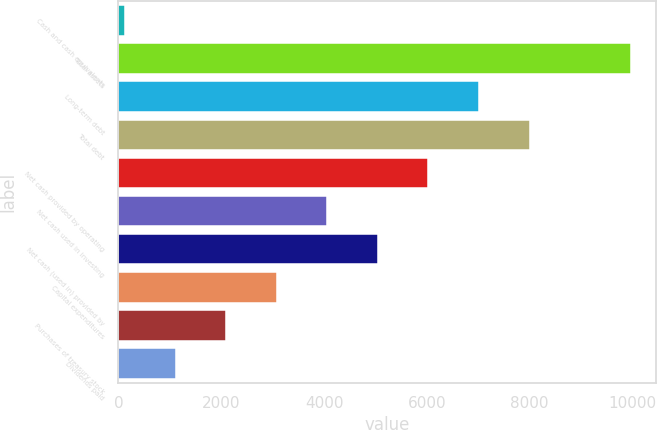Convert chart to OTSL. <chart><loc_0><loc_0><loc_500><loc_500><bar_chart><fcel>Cash and cash equivalents<fcel>Total assets<fcel>Long-term debt<fcel>Total debt<fcel>Net cash provided by operating<fcel>Net cash used in investing<fcel>Net cash (used in) provided by<fcel>Capital expenditures<fcel>Purchases of treasury stock<fcel>Dividends paid<nl><fcel>133<fcel>9962<fcel>7013.3<fcel>7996.2<fcel>6030.4<fcel>4064.6<fcel>5047.5<fcel>3081.7<fcel>2098.8<fcel>1115.9<nl></chart> 